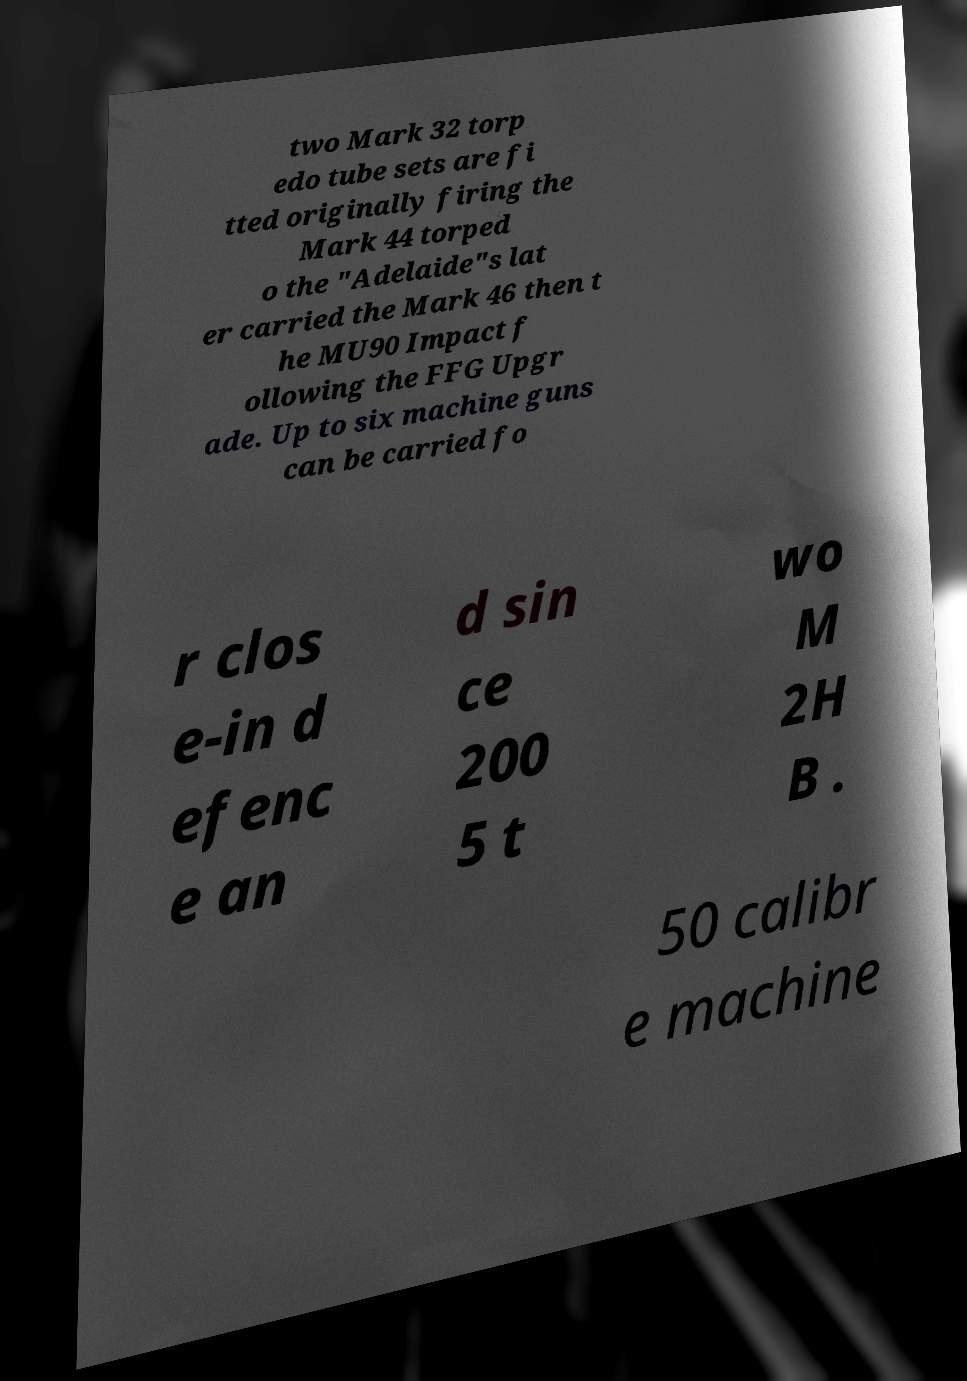Can you read and provide the text displayed in the image?This photo seems to have some interesting text. Can you extract and type it out for me? two Mark 32 torp edo tube sets are fi tted originally firing the Mark 44 torped o the "Adelaide"s lat er carried the Mark 46 then t he MU90 Impact f ollowing the FFG Upgr ade. Up to six machine guns can be carried fo r clos e-in d efenc e an d sin ce 200 5 t wo M 2H B . 50 calibr e machine 